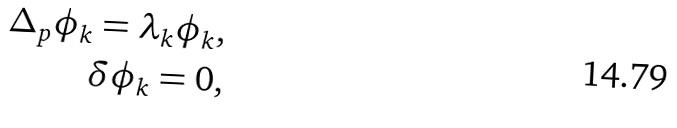Convert formula to latex. <formula><loc_0><loc_0><loc_500><loc_500>\Delta _ { p } \phi _ { k } = \lambda _ { k } \phi _ { k } , \\ \delta \phi _ { k } = 0 ,</formula> 